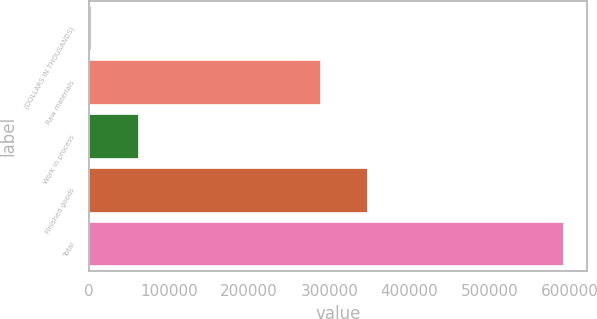Convert chart to OTSL. <chart><loc_0><loc_0><loc_500><loc_500><bar_chart><fcel>(DOLLARS IN THOUSANDS)<fcel>Raw materials<fcel>Work in process<fcel>Finished goods<fcel>Total<nl><fcel>2016<fcel>288629<fcel>61016.1<fcel>347629<fcel>592017<nl></chart> 